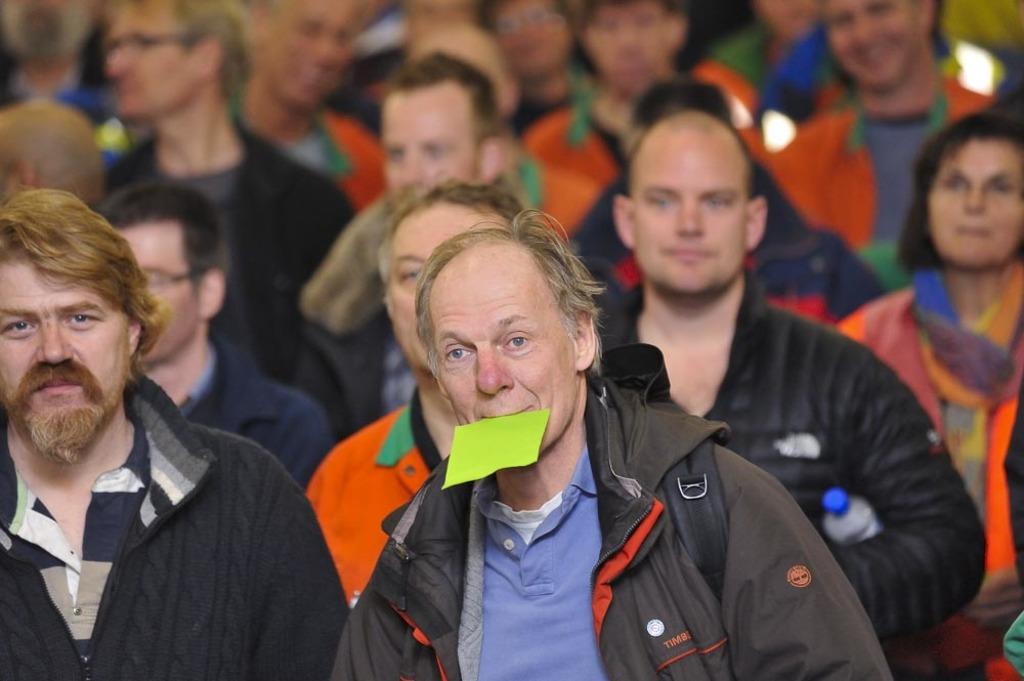How many people are in the image? There are multiple persons in the image. What are the majority of the persons wearing? Most of the persons are wearing jackets. What is one person in the middle doing in the image? One person in the middle is holding a paper in their mouth. What type of feast is being prepared by the persons in the image? There is no indication of a feast or any food preparation in the image. How many stars can be seen in the image? There are no stars visible in the image. 